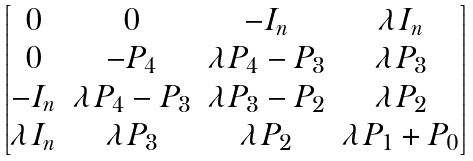<formula> <loc_0><loc_0><loc_500><loc_500>\begin{bmatrix} 0 & 0 & - I _ { n } & \lambda I _ { n } \\ 0 & - P _ { 4 } & \lambda P _ { 4 } - P _ { 3 } & \lambda P _ { 3 } \\ - I _ { n } & \lambda P _ { 4 } - P _ { 3 } & \lambda P _ { 3 } - P _ { 2 } & \lambda P _ { 2 } \\ \lambda I _ { n } & \lambda P _ { 3 } & \lambda P _ { 2 } & \lambda P _ { 1 } + P _ { 0 } \end{bmatrix}</formula> 